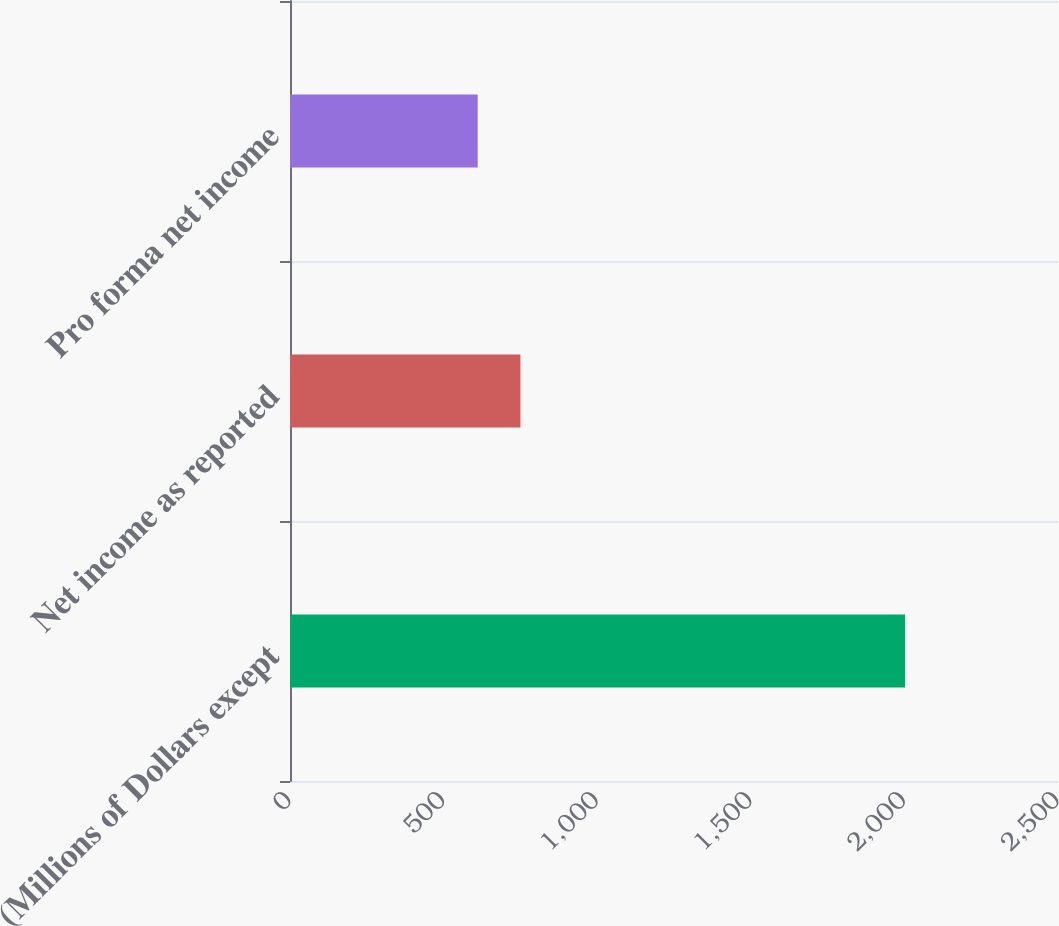<chart> <loc_0><loc_0><loc_500><loc_500><bar_chart><fcel>(Millions of Dollars except<fcel>Net income as reported<fcel>Pro forma net income<nl><fcel>2002<fcel>750.1<fcel>611<nl></chart> 